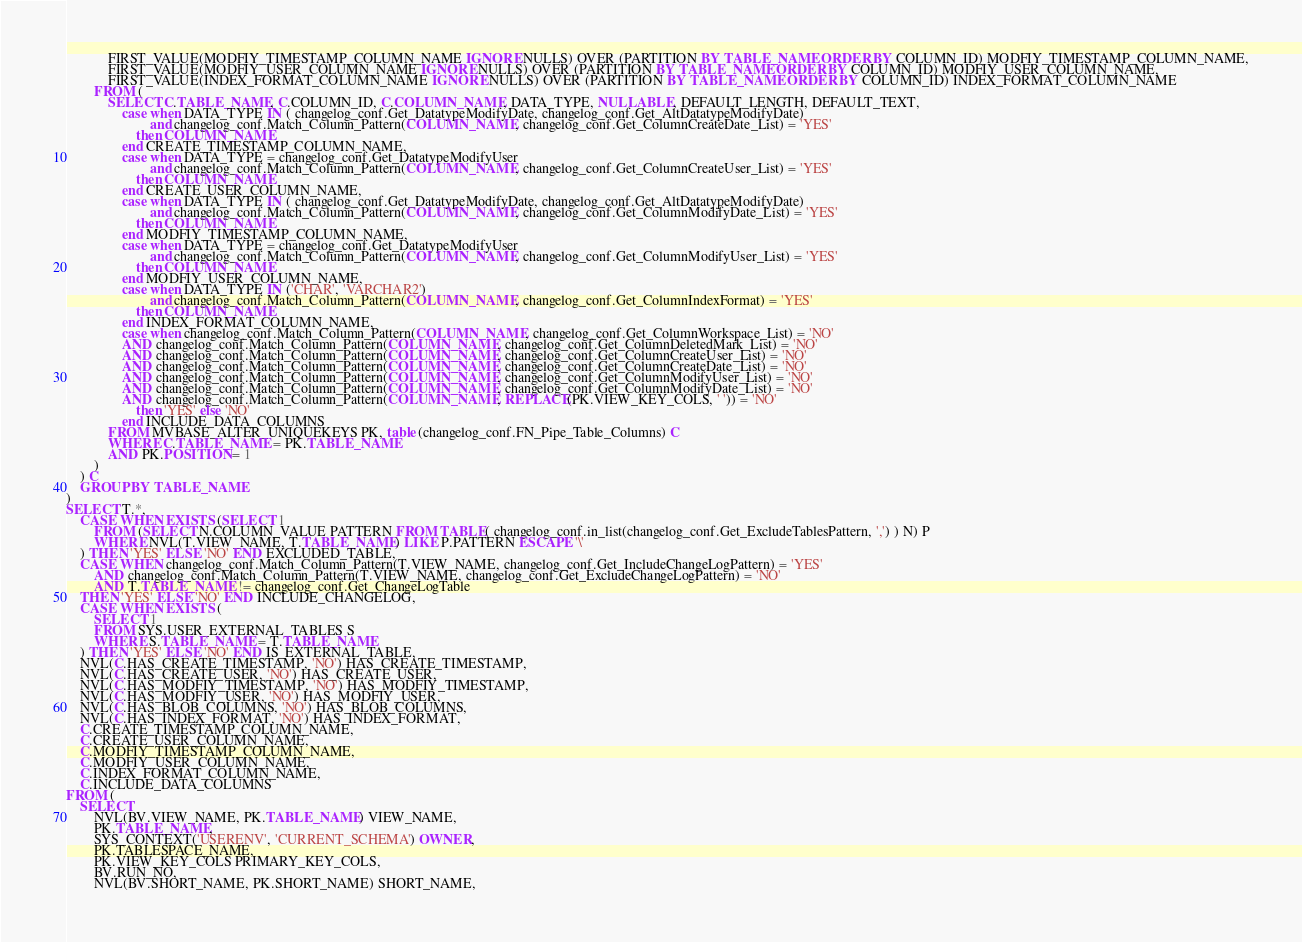<code> <loc_0><loc_0><loc_500><loc_500><_SQL_>			FIRST_VALUE(MODFIY_TIMESTAMP_COLUMN_NAME IGNORE NULLS) OVER (PARTITION BY TABLE_NAME ORDER BY COLUMN_ID) MODFIY_TIMESTAMP_COLUMN_NAME,
			FIRST_VALUE(MODFIY_USER_COLUMN_NAME IGNORE NULLS) OVER (PARTITION BY TABLE_NAME ORDER BY COLUMN_ID) MODFIY_USER_COLUMN_NAME,
			FIRST_VALUE(INDEX_FORMAT_COLUMN_NAME IGNORE NULLS) OVER (PARTITION BY TABLE_NAME ORDER BY COLUMN_ID) INDEX_FORMAT_COLUMN_NAME
		FROM (
			SELECT C.TABLE_NAME, C.COLUMN_ID, C.COLUMN_NAME, DATA_TYPE, NULLABLE, DEFAULT_LENGTH, DEFAULT_TEXT,
				case when DATA_TYPE IN ( changelog_conf.Get_DatatypeModifyDate, changelog_conf.Get_AltDatatypeModifyDate) 
						and changelog_conf.Match_Column_Pattern(COLUMN_NAME, changelog_conf.Get_ColumnCreateDate_List) = 'YES'
					then COLUMN_NAME
				end CREATE_TIMESTAMP_COLUMN_NAME,
				case when DATA_TYPE = changelog_conf.Get_DatatypeModifyUser 
						and changelog_conf.Match_Column_Pattern(COLUMN_NAME, changelog_conf.Get_ColumnCreateUser_List) = 'YES'
					then COLUMN_NAME
				end CREATE_USER_COLUMN_NAME,
				case when DATA_TYPE IN ( changelog_conf.Get_DatatypeModifyDate, changelog_conf.Get_AltDatatypeModifyDate) 
						and changelog_conf.Match_Column_Pattern(COLUMN_NAME, changelog_conf.Get_ColumnModifyDate_List) = 'YES'
					then COLUMN_NAME
				end MODFIY_TIMESTAMP_COLUMN_NAME,
				case when DATA_TYPE = changelog_conf.Get_DatatypeModifyUser 
						and changelog_conf.Match_Column_Pattern(COLUMN_NAME, changelog_conf.Get_ColumnModifyUser_List) = 'YES'
					then COLUMN_NAME
				end MODFIY_USER_COLUMN_NAME,
				case when DATA_TYPE IN ('CHAR', 'VARCHAR2') 
						and changelog_conf.Match_Column_Pattern(COLUMN_NAME, changelog_conf.Get_ColumnIndexFormat) = 'YES'
					then COLUMN_NAME
				end INDEX_FORMAT_COLUMN_NAME,
				case when changelog_conf.Match_Column_Pattern(COLUMN_NAME, changelog_conf.Get_ColumnWorkspace_List) = 'NO'
				AND changelog_conf.Match_Column_Pattern(COLUMN_NAME, changelog_conf.Get_ColumnDeletedMark_List) = 'NO'
				AND changelog_conf.Match_Column_Pattern(COLUMN_NAME, changelog_conf.Get_ColumnCreateUser_List) = 'NO'
				AND changelog_conf.Match_Column_Pattern(COLUMN_NAME, changelog_conf.Get_ColumnCreateDate_List) = 'NO'
				AND changelog_conf.Match_Column_Pattern(COLUMN_NAME, changelog_conf.Get_ColumnModifyUser_List) = 'NO'
				AND changelog_conf.Match_Column_Pattern(COLUMN_NAME, changelog_conf.Get_ColumnModifyDate_List) = 'NO'
				AND changelog_conf.Match_Column_Pattern(COLUMN_NAME, REPLACE(PK.VIEW_KEY_COLS, ' ')) = 'NO'
					then 'YES' else 'NO' 
				end INCLUDE_DATA_COLUMNS
			FROM MVBASE_ALTER_UNIQUEKEYS PK, table (changelog_conf.FN_Pipe_Table_Columns) C
			WHERE C.TABLE_NAME = PK.TABLE_NAME
			AND PK.POSITION = 1
		)
	) C
	GROUP BY TABLE_NAME
)
SELECT T.*,
	CASE WHEN EXISTS (SELECT 1
		FROM (SELECT N.COLUMN_VALUE PATTERN FROM TABLE( changelog_conf.in_list(changelog_conf.Get_ExcludeTablesPattern, ',') ) N) P
		WHERE NVL(T.VIEW_NAME, T.TABLE_NAME) LIKE P.PATTERN ESCAPE '\'
	) THEN 'YES' ELSE 'NO' END EXCLUDED_TABLE,
	CASE WHEN changelog_conf.Match_Column_Pattern(T.VIEW_NAME, changelog_conf.Get_IncludeChangeLogPattern) = 'YES'
		AND changelog_conf.Match_Column_Pattern(T.VIEW_NAME, changelog_conf.Get_ExcludeChangeLogPattern) = 'NO'
		AND T.TABLE_NAME != changelog_conf.Get_ChangeLogTable
	THEN 'YES' ELSE 'NO' END INCLUDE_CHANGELOG,
	CASE WHEN EXISTS (
		SELECT 1 
		FROM SYS.USER_EXTERNAL_TABLES S
		WHERE S.TABLE_NAME = T.TABLE_NAME
	) THEN 'YES' ELSE 'NO' END IS_EXTERNAL_TABLE,
	NVL(C.HAS_CREATE_TIMESTAMP, 'NO') HAS_CREATE_TIMESTAMP,
	NVL(C.HAS_CREATE_USER, 'NO') HAS_CREATE_USER,
	NVL(C.HAS_MODFIY_TIMESTAMP, 'NO') HAS_MODFIY_TIMESTAMP,
	NVL(C.HAS_MODFIY_USER, 'NO') HAS_MODFIY_USER,
	NVL(C.HAS_BLOB_COLUMNS, 'NO') HAS_BLOB_COLUMNS,
	NVL(C.HAS_INDEX_FORMAT, 'NO') HAS_INDEX_FORMAT,
    C.CREATE_TIMESTAMP_COLUMN_NAME, 
    C.CREATE_USER_COLUMN_NAME, 
    C.MODFIY_TIMESTAMP_COLUMN_NAME, 
    C.MODFIY_USER_COLUMN_NAME, 
    C.INDEX_FORMAT_COLUMN_NAME, 
    C.INCLUDE_DATA_COLUMNS
FROM (
	SELECT  
		NVL(BV.VIEW_NAME, PK.TABLE_NAME) VIEW_NAME, 
		PK.TABLE_NAME, 
		SYS_CONTEXT('USERENV', 'CURRENT_SCHEMA') OWNER,
		PK.TABLESPACE_NAME,
		PK.VIEW_KEY_COLS PRIMARY_KEY_COLS,
		BV.RUN_NO,
		NVL(BV.SHORT_NAME, PK.SHORT_NAME) SHORT_NAME,</code> 